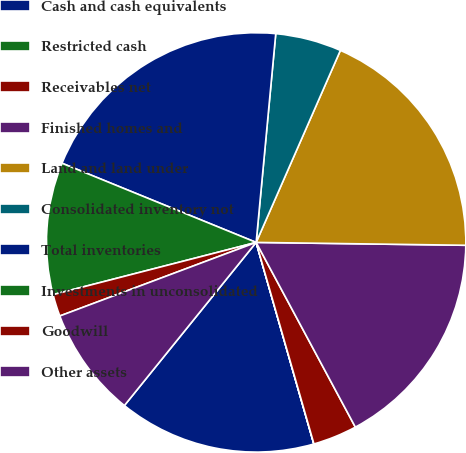<chart> <loc_0><loc_0><loc_500><loc_500><pie_chart><fcel>Cash and cash equivalents<fcel>Restricted cash<fcel>Receivables net<fcel>Finished homes and<fcel>Land and land under<fcel>Consolidated inventory not<fcel>Total inventories<fcel>Investments in unconsolidated<fcel>Goodwill<fcel>Other assets<nl><fcel>15.25%<fcel>0.01%<fcel>3.4%<fcel>16.94%<fcel>18.64%<fcel>5.09%<fcel>20.33%<fcel>10.17%<fcel>1.7%<fcel>8.48%<nl></chart> 